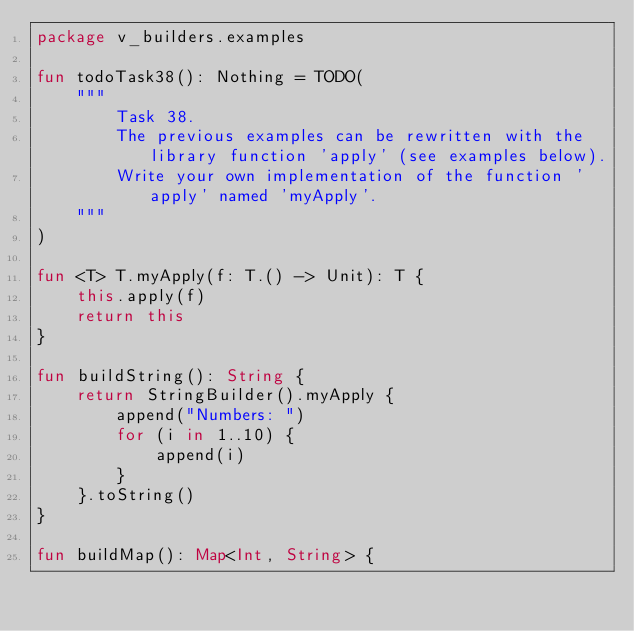<code> <loc_0><loc_0><loc_500><loc_500><_Kotlin_>package v_builders.examples

fun todoTask38(): Nothing = TODO(
    """
        Task 38.
        The previous examples can be rewritten with the library function 'apply' (see examples below).
        Write your own implementation of the function 'apply' named 'myApply'.
    """
)

fun <T> T.myApply(f: T.() -> Unit): T {
    this.apply(f)
    return this
}

fun buildString(): String {
    return StringBuilder().myApply {
        append("Numbers: ")
        for (i in 1..10) {
            append(i)
        }
    }.toString()
}

fun buildMap(): Map<Int, String> {</code> 